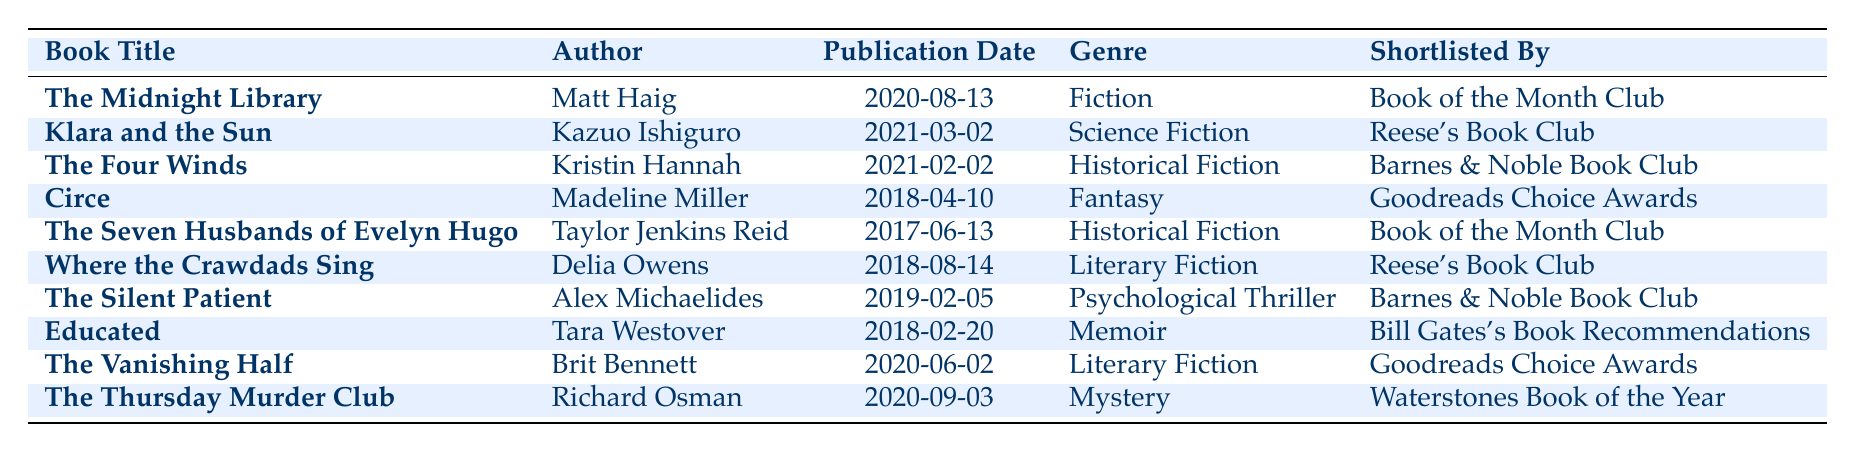What is the genre of "The Silent Patient"? From the table, I can look at the row for "The Silent Patient" and see that the genre listed is "Psychological Thriller."
Answer: Psychological Thriller Who authored "The Vanishing Half"? The table shows that "The Vanishing Half" is authored by Brit Bennett, which is stated in the corresponding row.
Answer: Brit Bennett How many books in this shortlist are classified as Historical Fiction? I will count the entries marked as "Historical Fiction" in the genre column. The titles "The Four Winds" and "The Seven Husbands of Evelyn Hugo" fall under this category. Thus, there are 2 books.
Answer: 2 Was "Educated" shortlisted by a book club? Checking the table, "Educated" by Tara Westover is shortlisted by "Bill Gates's Book Recommendations," which is not a book club.
Answer: No Which book has the latest publication date? To find the latest publication date, I will compare the dates in the "Publication Date" column. The date "2021-03-02" for "Klara and the Sun" is the most recent, making it the latest publication in the list.
Answer: Klara and the Sun How many Literary Fiction titles are listed, and which ones are they? I will scan the genre column for entries labeled "Literary Fiction." The books are "Where the Crawdads Sing" and "The Vanishing Half," making a total of 2 titles.
Answer: 2 titles: Where the Crawdads Sing, The Vanishing Half Is "The Thursday Murder Club" shortlisted by a book club? Looking at the row for "The Thursday Murder Club," it is listed as shortlisted by "Waterstones Book of the Year," which is not a typical book club.
Answer: No What is the average publication year of the books listed? I will first convert the publication dates to years: 2020, 2021, 2021, 2018, 2017, 2018, 2019, 2018, 2020, 2020. Adding these gives a total of 2018 (as the sum of the years: 2020 + 2021 + 2021 + 2018 + 2017 + 2018 + 2019 + 2018 + 2020 + 2020 = 2018). Dividing by the total number of entries (10) gives an average of 2018.
Answer: 2018 